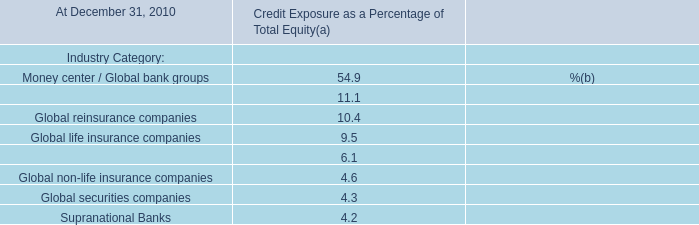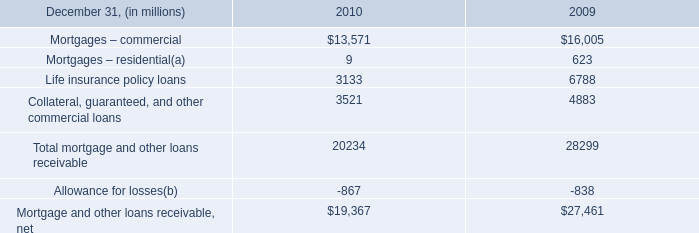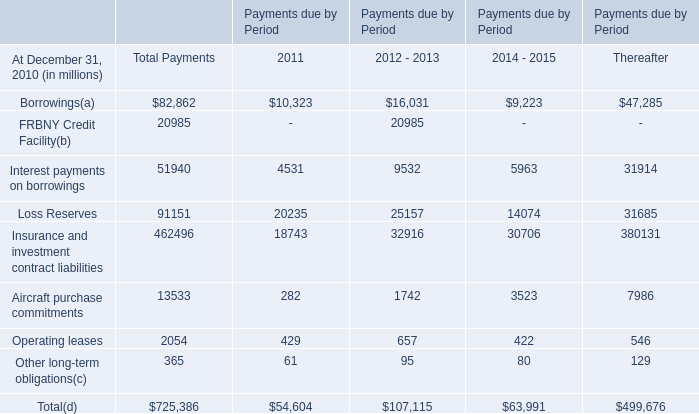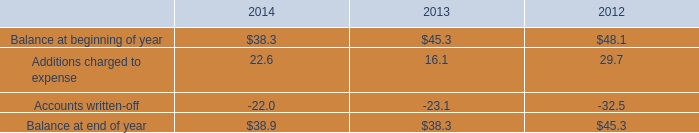In the year with largest amount of insurance and investment contract liabilities , what's the increasing rate of Aircraft purchase commitments? 
Computations: ((1742 - 282) / 282)
Answer: 5.1773. 